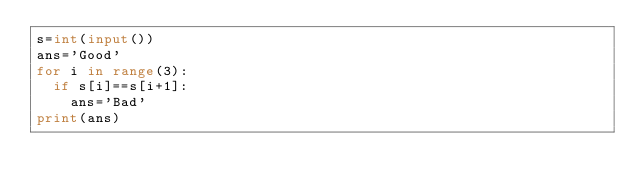<code> <loc_0><loc_0><loc_500><loc_500><_Python_>s=int(input())
ans='Good'
for i in range(3):
  if s[i]==s[i+1]:
    ans='Bad'
print(ans)</code> 